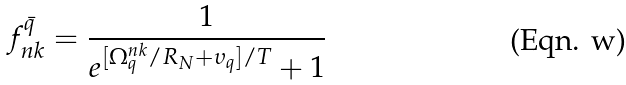Convert formula to latex. <formula><loc_0><loc_0><loc_500><loc_500>f ^ { \bar { q } } _ { n k } = \frac { 1 } { e ^ { [ \Omega _ { q } ^ { n k } / R _ { N } + \upsilon _ { q } ] / T } + 1 }</formula> 